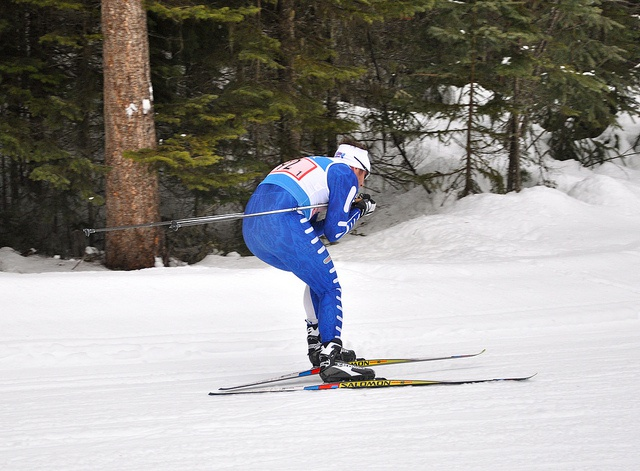Describe the objects in this image and their specific colors. I can see people in black, blue, and lavender tones, skis in black, lightgray, gray, and darkgray tones, and skis in black, lightgray, gray, darkgray, and olive tones in this image. 